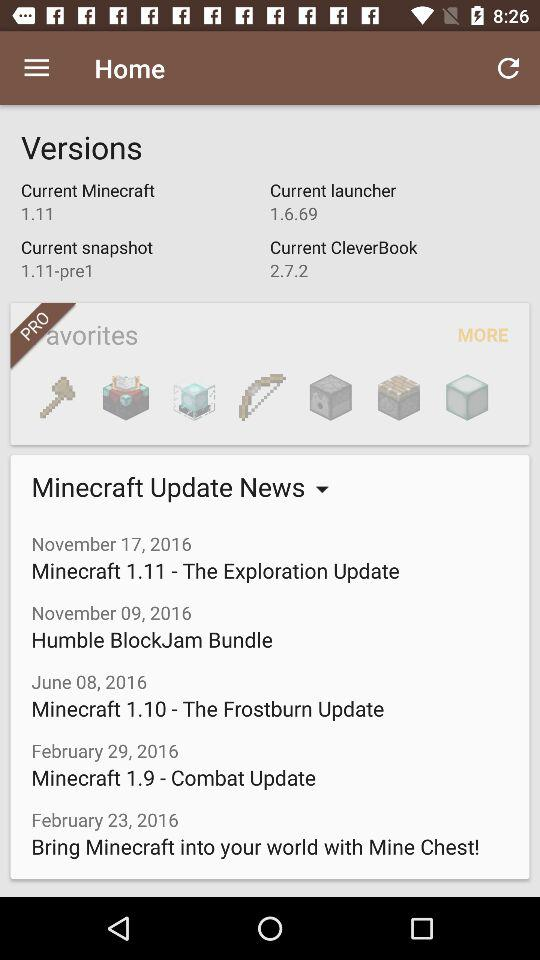What is the "Current launcher" version? The "Current launcher" version is 1.6.69. 